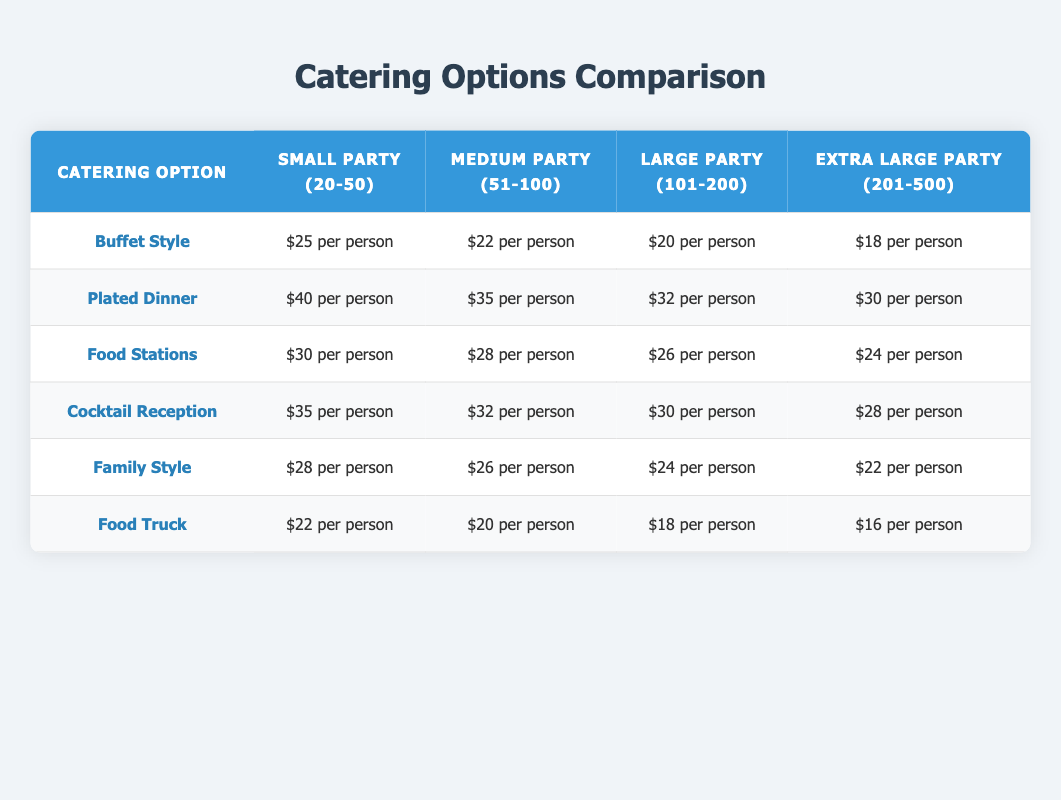What is the cost per person for buffet style catering for a medium party? Looking at the row for "Buffet Style" under the "Medium Party (51-100)" column, the cost is "$22 per person."
Answer: $22 per person What is the cheapest catering option for an extra large party? Analyzing the "Extra Large Party (201-500)" column, the cheapest option is "Food Truck" at "$16 per person."
Answer: $16 per person Which party size has the highest cost for a plated dinner? The "Plated Dinner" row shows that the "Small Party (20-50)" has the highest cost at "$40 per person."
Answer: $40 per person What is the total cost for a family style catering for a large party of 150 people? The cost for "Family Style" for a large party is "$24 per person." Therefore, for 150 people, the total cost is calculated as 150 * 24 = $3600.
Answer: $3600 Is the cost per person for a food truck less than that of a buffet style for a small party? For a small party, the cost of "Food Truck" is "$22 per person" and "Buffet Style" is "$25 per person." Since $22 is less than $25, the answer is yes.
Answer: Yes What catering option has the most significant cost difference between small and extra large parties? By comparing the costs across all options, "Plated Dinner" has the largest difference: $40 (small) - $30 (extra large) = $10.
Answer: Plated Dinner What is the average cost difference for food stations from small to extra large parties? The costs for food stations are $30 (small) and $24 (extra large). The difference is $30 - $24 = $6. The average difference across these two is 6/2 = $3.
Answer: $3 Does the cost decrease consistently for all catering options as the party size increases? Analyzing each catering row for patterns, it appears all options decrease in cost as the party size increases. Hence, the statement is true.
Answer: Yes 